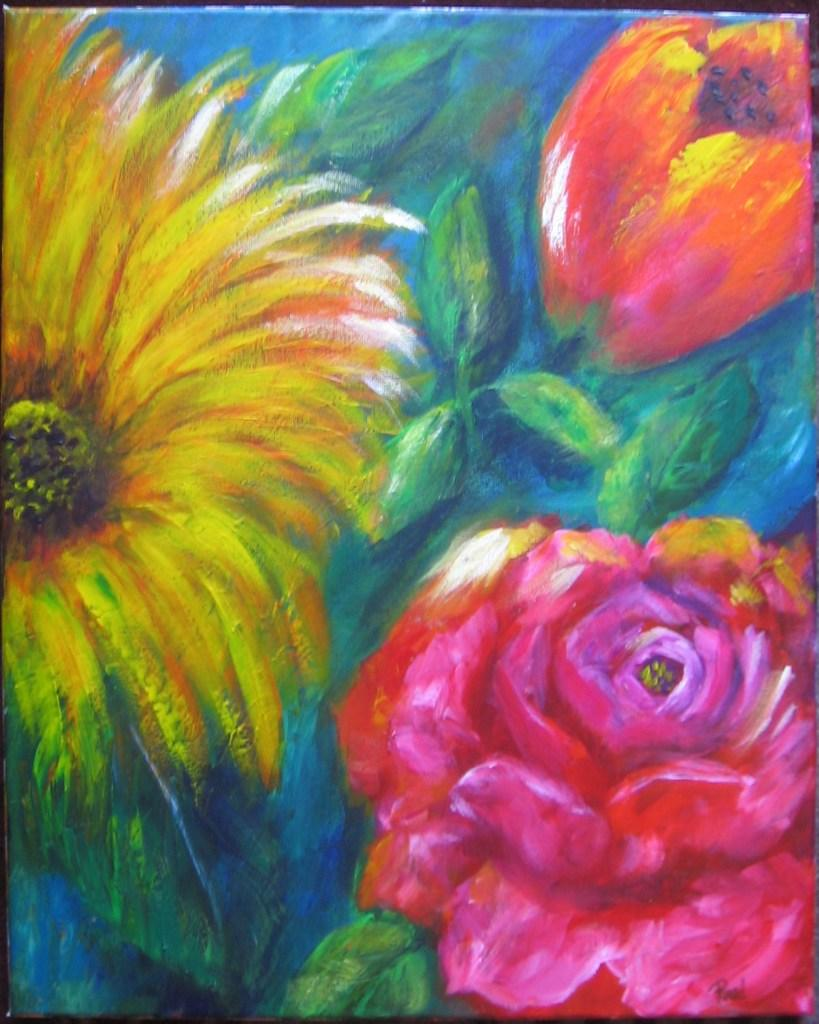What is the main subject of the painting in the image? The painting depicts flowers. Are there any other elements in the painting besides flowers? Yes, the painting also depicts leaves. What type of cheese is being discovered in the painting? There is no cheese present in the painting; it depicts flowers and leaves. 